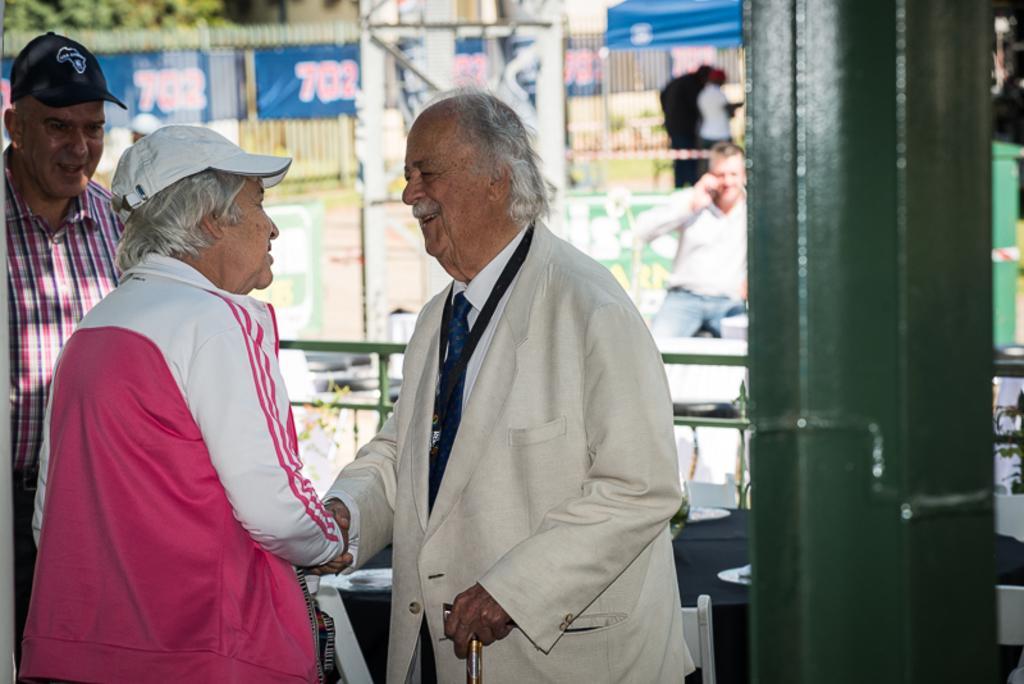Describe this image in one or two sentences. In this image we can see some people standing. In that a man is holding a stick. On the backside we can see a metal fence, pole, some banners on a fence, trees and a person sitting. 